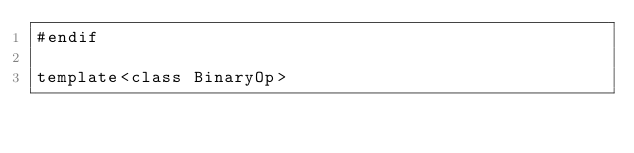<code> <loc_0><loc_0><loc_500><loc_500><_Cuda_>#endif

template<class BinaryOp></code> 